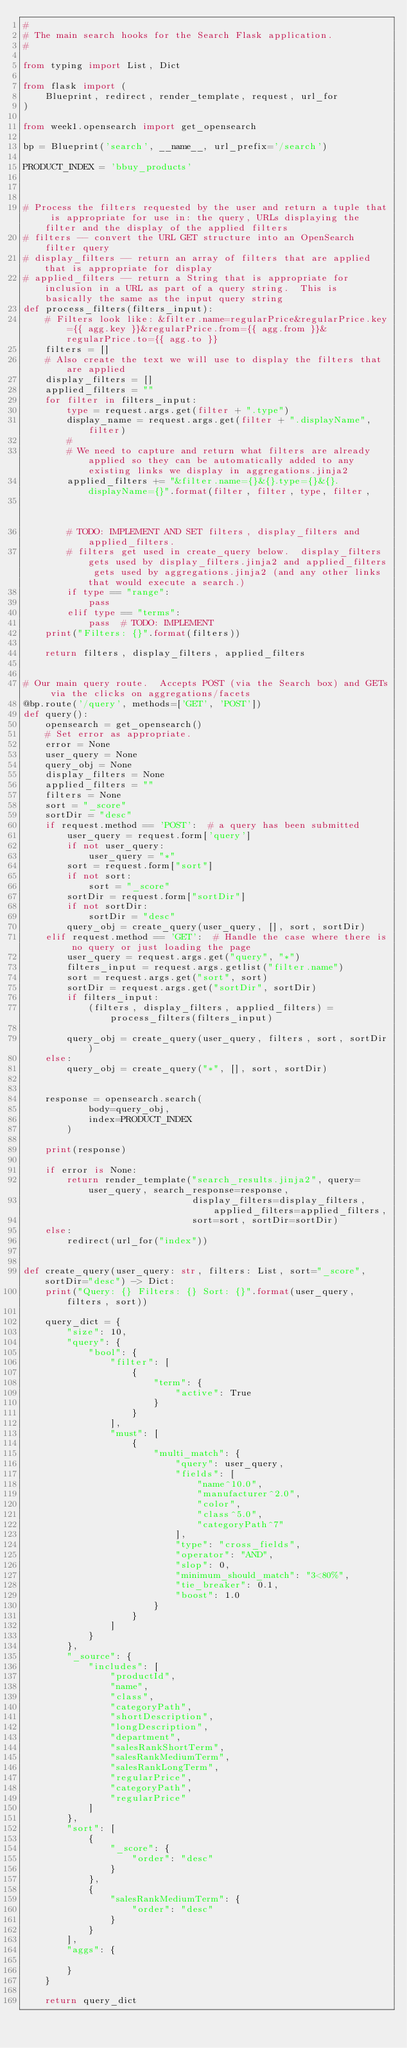<code> <loc_0><loc_0><loc_500><loc_500><_Python_>#
# The main search hooks for the Search Flask application.
#

from typing import List, Dict

from flask import (
    Blueprint, redirect, render_template, request, url_for
)

from week1.opensearch import get_opensearch

bp = Blueprint('search', __name__, url_prefix='/search')

PRODUCT_INDEX = 'bbuy_products'



# Process the filters requested by the user and return a tuple that is appropriate for use in: the query, URLs displaying the filter and the display of the applied filters
# filters -- convert the URL GET structure into an OpenSearch filter query
# display_filters -- return an array of filters that are applied that is appropriate for display
# applied_filters -- return a String that is appropriate for inclusion in a URL as part of a query string.  This is basically the same as the input query string
def process_filters(filters_input):
    # Filters look like: &filter.name=regularPrice&regularPrice.key={{ agg.key }}&regularPrice.from={{ agg.from }}&regularPrice.to={{ agg.to }}
    filters = []
    # Also create the text we will use to display the filters that are applied
    display_filters = []
    applied_filters = ""
    for filter in filters_input:
        type = request.args.get(filter + ".type")
        display_name = request.args.get(filter + ".displayName", filter)
        #
        # We need to capture and return what filters are already applied so they can be automatically added to any existing links we display in aggregations.jinja2
        applied_filters += "&filter.name={}&{}.type={}&{}.displayName={}".format(filter, filter, type, filter,
                                                                                 display_name)
        # TODO: IMPLEMENT AND SET filters, display_filters and applied_filters.
        # filters get used in create_query below.  display_filters gets used by display_filters.jinja2 and applied_filters gets used by aggregations.jinja2 (and any other links that would execute a search.)
        if type == "range":
            pass
        elif type == "terms":
            pass  # TODO: IMPLEMENT
    print("Filters: {}".format(filters))

    return filters, display_filters, applied_filters


# Our main query route.  Accepts POST (via the Search box) and GETs via the clicks on aggregations/facets
@bp.route('/query', methods=['GET', 'POST'])
def query():
    opensearch = get_opensearch()
    # Set error as appropriate.
    error = None
    user_query = None
    query_obj = None
    display_filters = None
    applied_filters = ""
    filters = None
    sort = "_score"
    sortDir = "desc"
    if request.method == 'POST':  # a query has been submitted
        user_query = request.form['query']
        if not user_query:
            user_query = "*"
        sort = request.form["sort"]
        if not sort:
            sort = "_score"
        sortDir = request.form["sortDir"]
        if not sortDir:
            sortDir = "desc"
        query_obj = create_query(user_query, [], sort, sortDir)
    elif request.method == 'GET':  # Handle the case where there is no query or just loading the page
        user_query = request.args.get("query", "*")
        filters_input = request.args.getlist("filter.name")
        sort = request.args.get("sort", sort)
        sortDir = request.args.get("sortDir", sortDir)
        if filters_input:
            (filters, display_filters, applied_filters) = process_filters(filters_input)

        query_obj = create_query(user_query, filters, sort, sortDir)
    else:
        query_obj = create_query("*", [], sort, sortDir)
        

    response = opensearch.search(
            body=query_obj,
            index=PRODUCT_INDEX
        )
    
    print(response)
    
    if error is None:
        return render_template("search_results.jinja2", query=user_query, search_response=response,
                               display_filters=display_filters, applied_filters=applied_filters,
                               sort=sort, sortDir=sortDir)
    else:
        redirect(url_for("index"))


def create_query(user_query: str, filters: List, sort="_score", sortDir="desc") -> Dict:
    print("Query: {} Filters: {} Sort: {}".format(user_query, filters, sort))

    query_dict = {
        "size": 10,
        "query": {
            "bool": {
                "filter": [
                    {
                        "term": {
                            "active": True
                        }
                    }
                ],
                "must": [
                    {
                        "multi_match": {
                            "query": user_query,
                            "fields": [
                                "name^10.0",
                                "manufacturer^2.0",
                                "color",
                                "class^5.0",
                                "categoryPath^7"
                            ],
                            "type": "cross_fields",
                            "operator": "AND",
                            "slop": 0,
                            "minimum_should_match": "3<80%",
                            "tie_breaker": 0.1,
                            "boost": 1.0
                        }
                    }
                ]
            }
        },
        "_source": {
            "includes": [
                "productId",
                "name",
                "class",
                "categoryPath",
                "shortDescription",
                "longDescription",
                "department",
                "salesRankShortTerm",
                "salesRankMediumTerm",
                "salesRankLongTerm",
                "regularPrice",
                "categoryPath",
                "regularPrice"
            ]
        },
        "sort": [
            {
                "_score": {
                    "order": "desc"
                }
            },
            {
                "salesRankMediumTerm": {
                    "order": "desc"
                }
            }
        ],
        "aggs": {
            
        }
    }

    return query_dict
</code> 